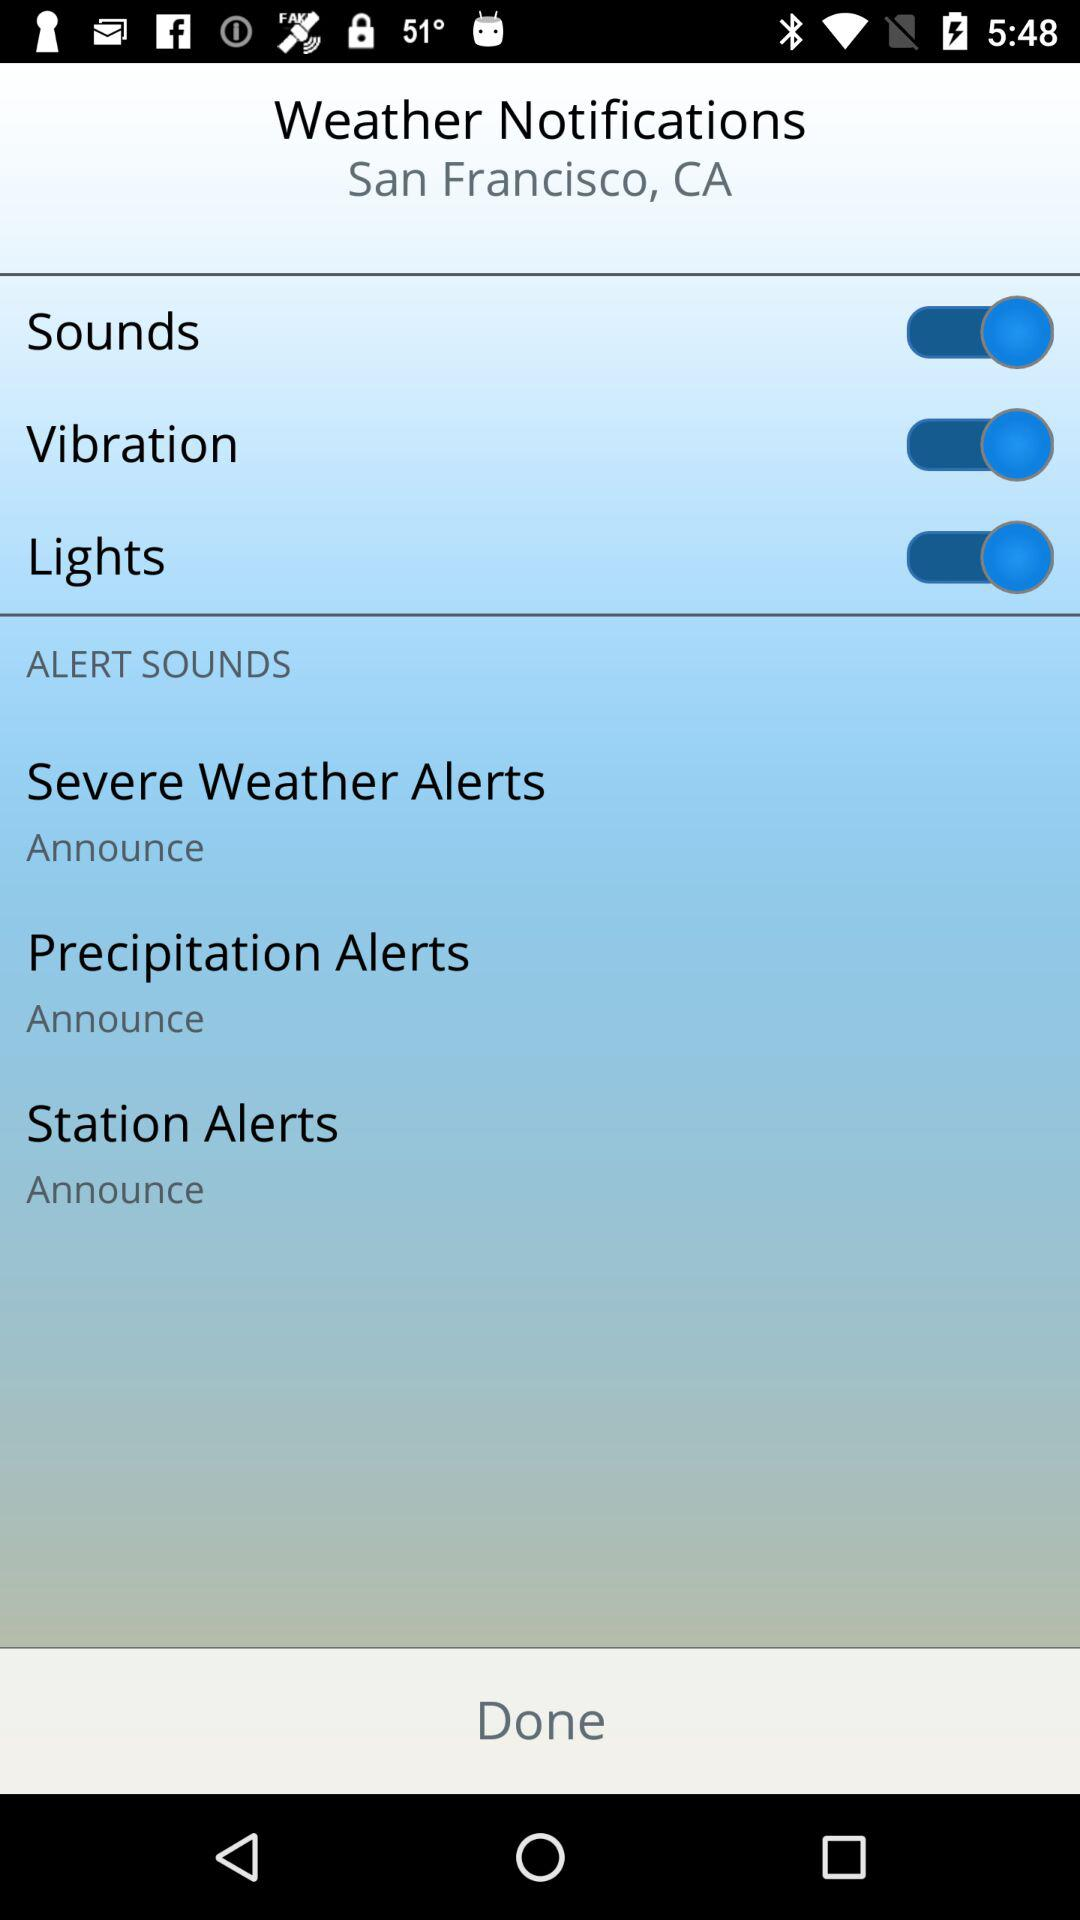What is the status of "Vibration" for weather notifications? The status of "Vibration" for weather notifications is "on". 